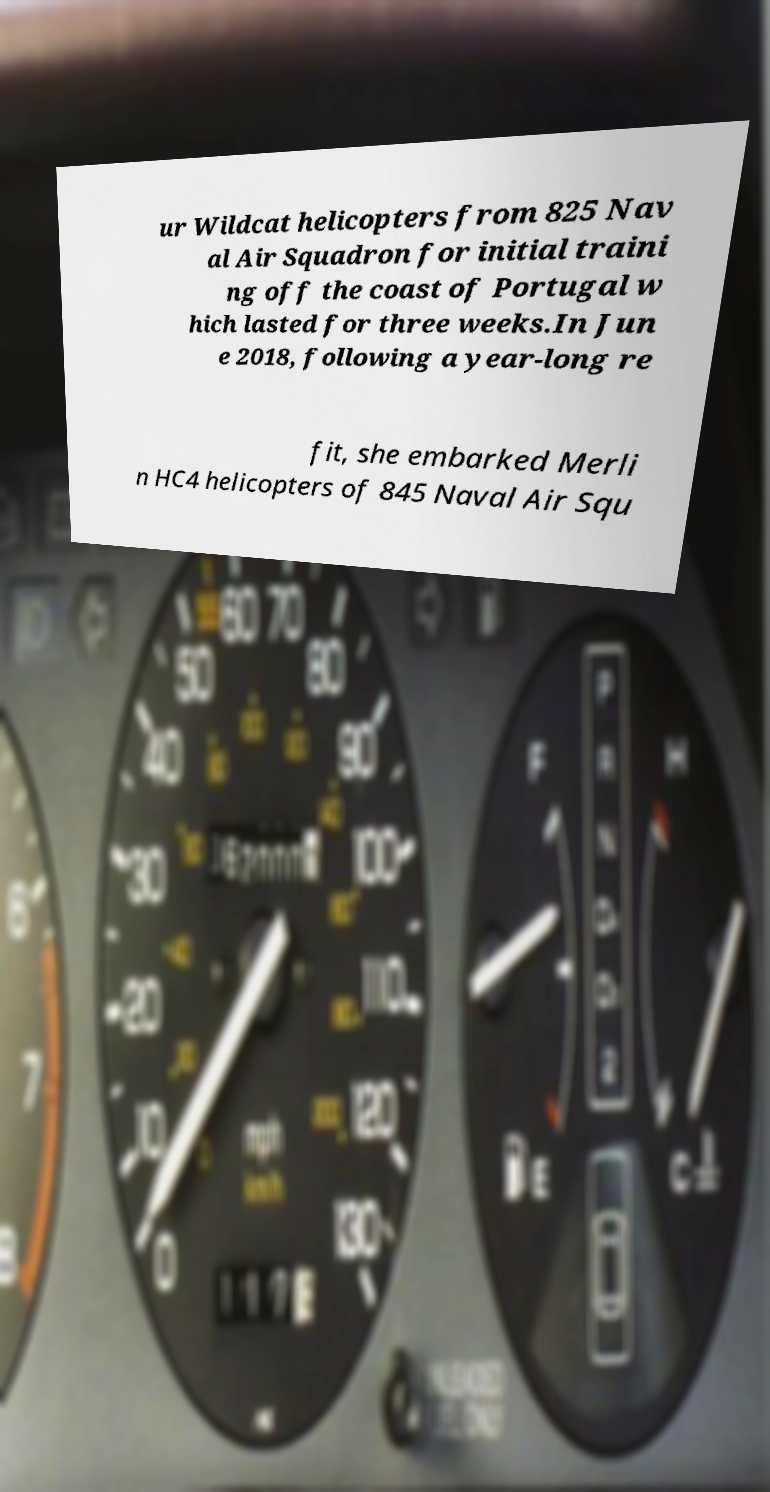Could you assist in decoding the text presented in this image and type it out clearly? ur Wildcat helicopters from 825 Nav al Air Squadron for initial traini ng off the coast of Portugal w hich lasted for three weeks.In Jun e 2018, following a year-long re fit, she embarked Merli n HC4 helicopters of 845 Naval Air Squ 